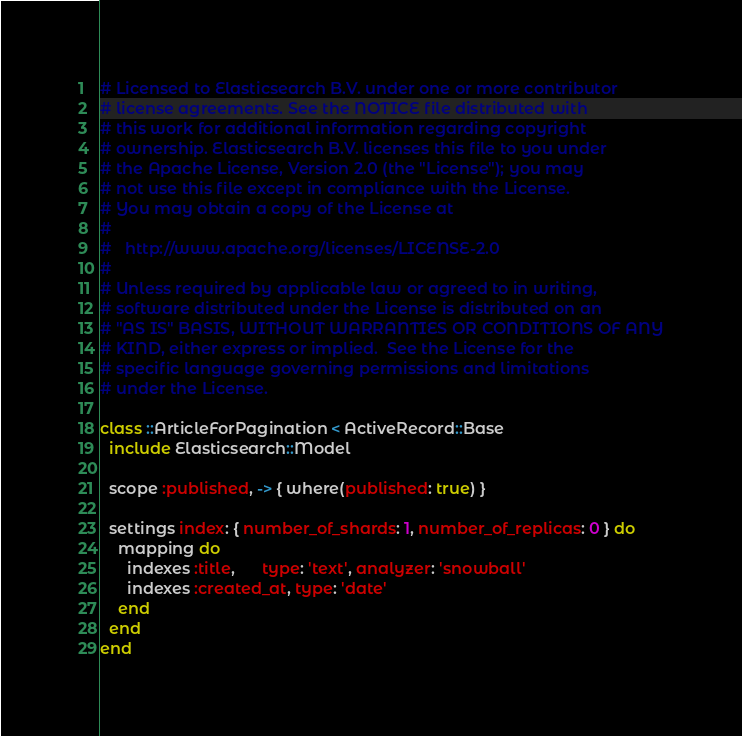Convert code to text. <code><loc_0><loc_0><loc_500><loc_500><_Ruby_># Licensed to Elasticsearch B.V. under one or more contributor
# license agreements. See the NOTICE file distributed with
# this work for additional information regarding copyright
# ownership. Elasticsearch B.V. licenses this file to you under
# the Apache License, Version 2.0 (the "License"); you may
# not use this file except in compliance with the License.
# You may obtain a copy of the License at
#
#   http://www.apache.org/licenses/LICENSE-2.0
#
# Unless required by applicable law or agreed to in writing,
# software distributed under the License is distributed on an
# "AS IS" BASIS, WITHOUT WARRANTIES OR CONDITIONS OF ANY
# KIND, either express or implied.  See the License for the
# specific language governing permissions and limitations
# under the License.

class ::ArticleForPagination < ActiveRecord::Base
  include Elasticsearch::Model

  scope :published, -> { where(published: true) }

  settings index: { number_of_shards: 1, number_of_replicas: 0 } do
    mapping do
      indexes :title,      type: 'text', analyzer: 'snowball'
      indexes :created_at, type: 'date'
    end
  end
end
</code> 